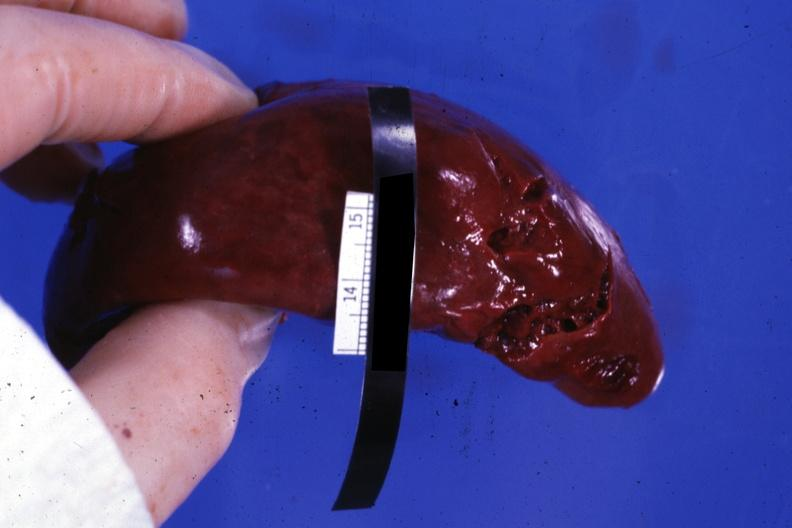s laceration present?
Answer the question using a single word or phrase. Yes 